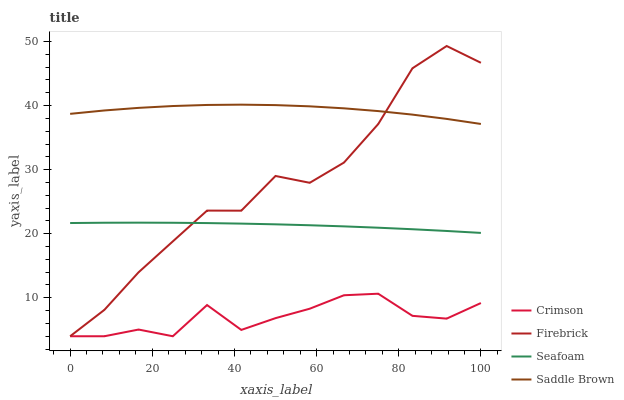Does Crimson have the minimum area under the curve?
Answer yes or no. Yes. Does Saddle Brown have the maximum area under the curve?
Answer yes or no. Yes. Does Firebrick have the minimum area under the curve?
Answer yes or no. No. Does Firebrick have the maximum area under the curve?
Answer yes or no. No. Is Seafoam the smoothest?
Answer yes or no. Yes. Is Firebrick the roughest?
Answer yes or no. Yes. Is Firebrick the smoothest?
Answer yes or no. No. Is Seafoam the roughest?
Answer yes or no. No. Does Crimson have the lowest value?
Answer yes or no. Yes. Does Seafoam have the lowest value?
Answer yes or no. No. Does Firebrick have the highest value?
Answer yes or no. Yes. Does Seafoam have the highest value?
Answer yes or no. No. Is Seafoam less than Saddle Brown?
Answer yes or no. Yes. Is Saddle Brown greater than Seafoam?
Answer yes or no. Yes. Does Saddle Brown intersect Firebrick?
Answer yes or no. Yes. Is Saddle Brown less than Firebrick?
Answer yes or no. No. Is Saddle Brown greater than Firebrick?
Answer yes or no. No. Does Seafoam intersect Saddle Brown?
Answer yes or no. No. 